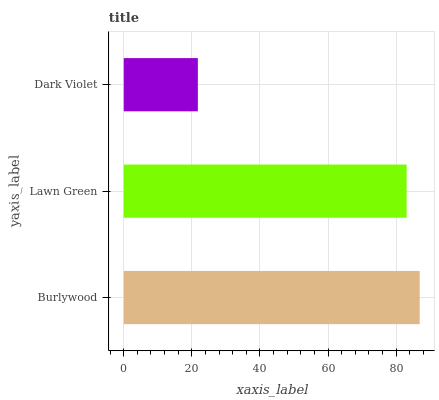Is Dark Violet the minimum?
Answer yes or no. Yes. Is Burlywood the maximum?
Answer yes or no. Yes. Is Lawn Green the minimum?
Answer yes or no. No. Is Lawn Green the maximum?
Answer yes or no. No. Is Burlywood greater than Lawn Green?
Answer yes or no. Yes. Is Lawn Green less than Burlywood?
Answer yes or no. Yes. Is Lawn Green greater than Burlywood?
Answer yes or no. No. Is Burlywood less than Lawn Green?
Answer yes or no. No. Is Lawn Green the high median?
Answer yes or no. Yes. Is Lawn Green the low median?
Answer yes or no. Yes. Is Burlywood the high median?
Answer yes or no. No. Is Burlywood the low median?
Answer yes or no. No. 